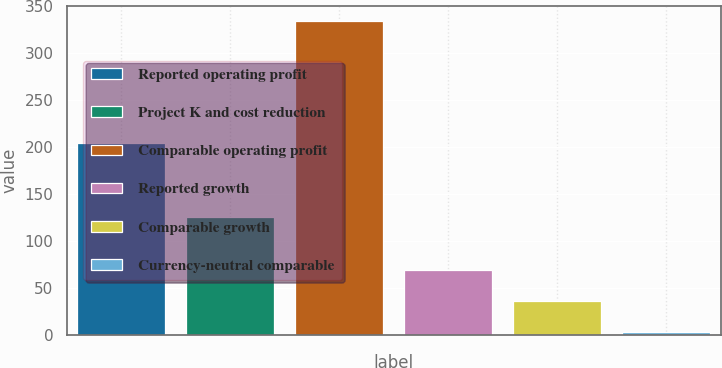Convert chart to OTSL. <chart><loc_0><loc_0><loc_500><loc_500><bar_chart><fcel>Reported operating profit<fcel>Project K and cost reduction<fcel>Comparable operating profit<fcel>Reported growth<fcel>Comparable growth<fcel>Currency-neutral comparable<nl><fcel>205<fcel>126<fcel>334<fcel>69.52<fcel>36.46<fcel>3.4<nl></chart> 